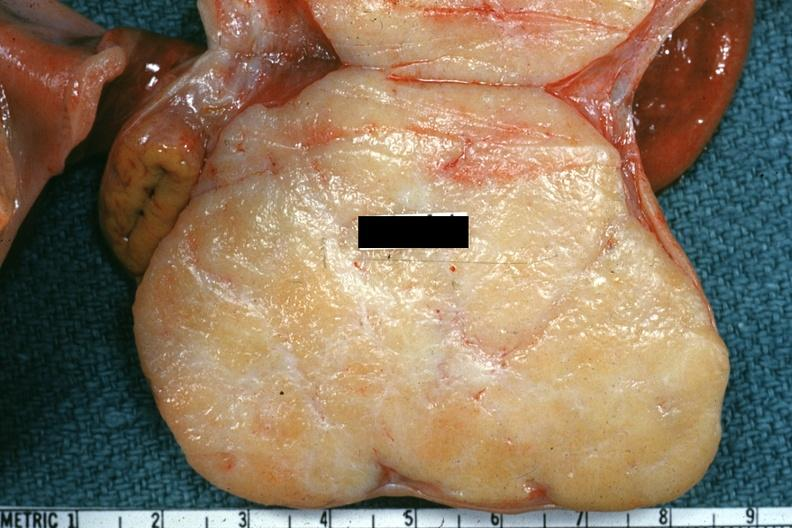s fibrotic lesion present?
Answer the question using a single word or phrase. No 